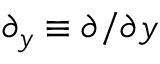<formula> <loc_0><loc_0><loc_500><loc_500>\partial _ { y } \equiv \partial / \partial y</formula> 